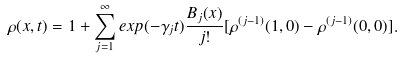Convert formula to latex. <formula><loc_0><loc_0><loc_500><loc_500>\rho ( x , t ) = 1 + \sum _ { j = 1 } ^ { \infty } e x p ( - \gamma _ { j } t ) \frac { B _ { j } ( x ) } { j ! } [ \rho ^ { ( j - 1 ) } ( 1 , 0 ) - \rho ^ { ( j - 1 ) } ( 0 , 0 ) ] .</formula> 